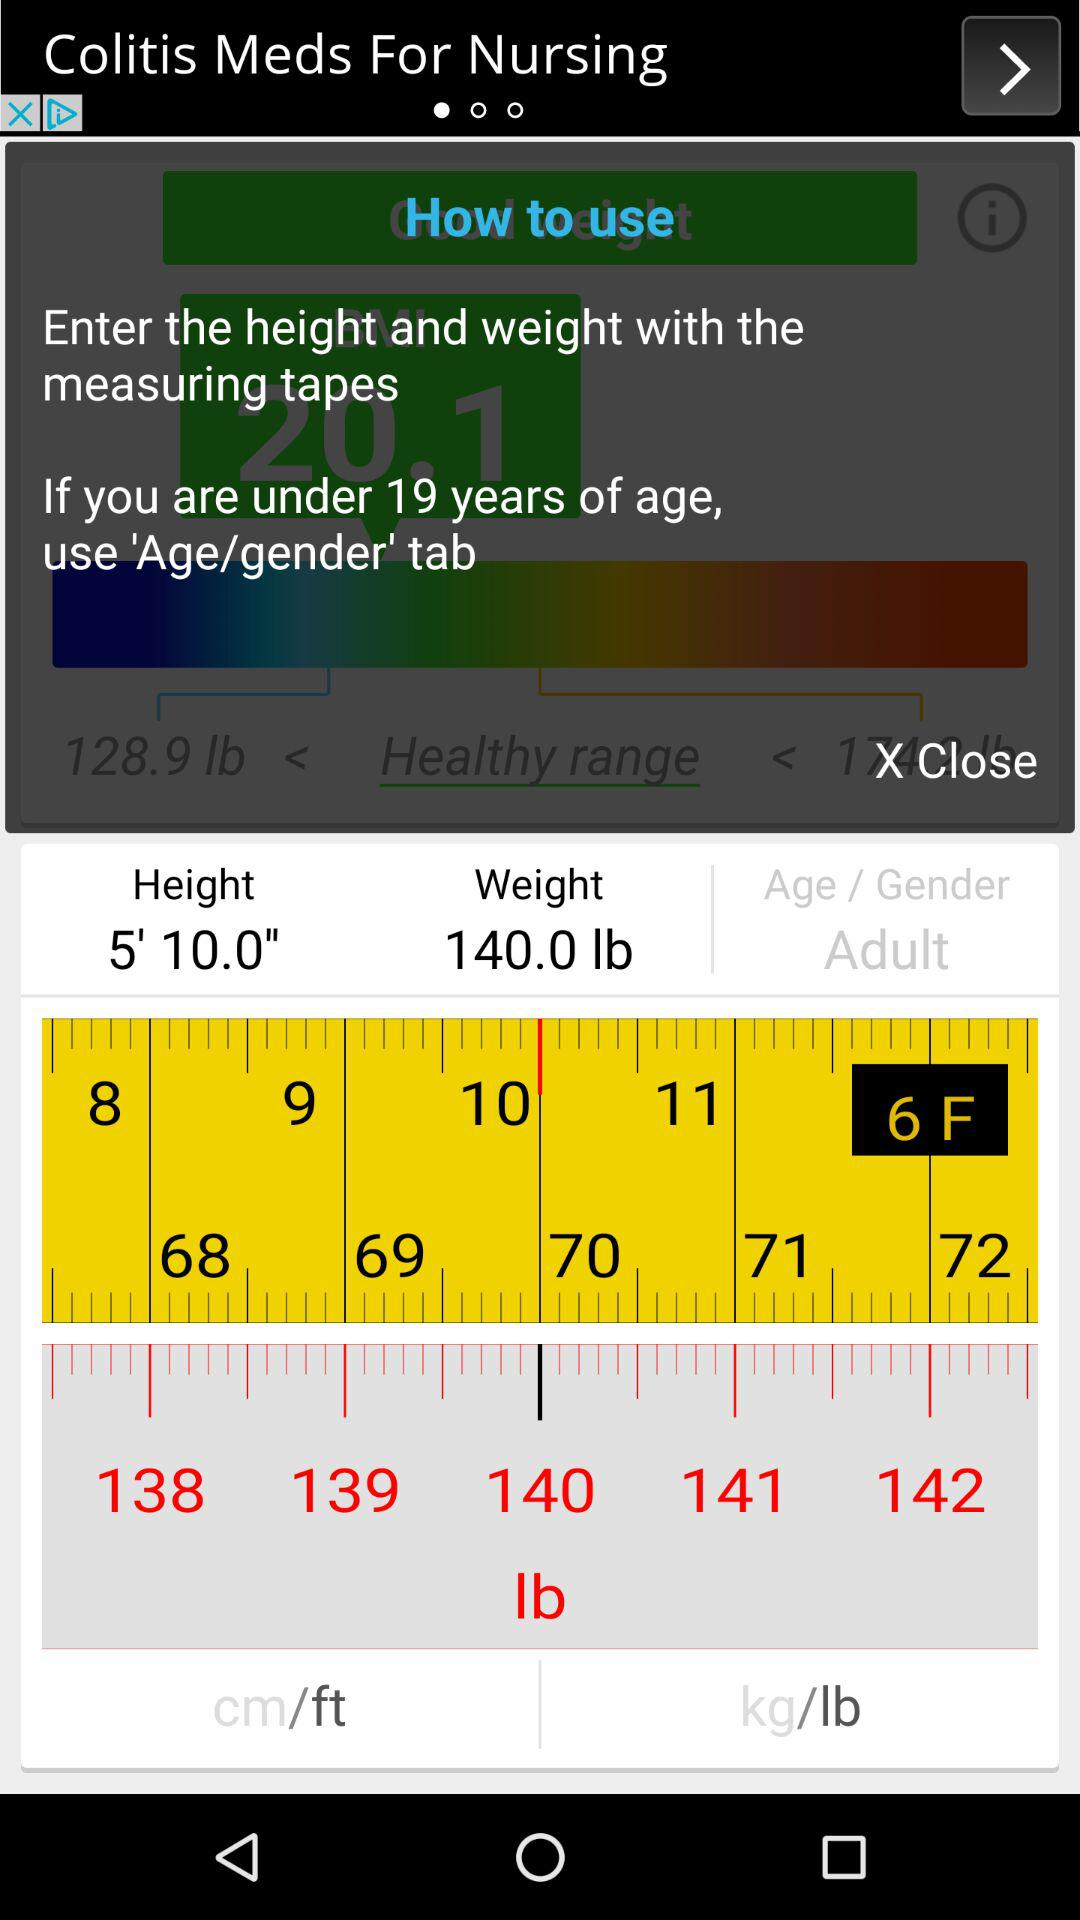What is the height of the person in inches?
Answer the question using a single word or phrase. 70 